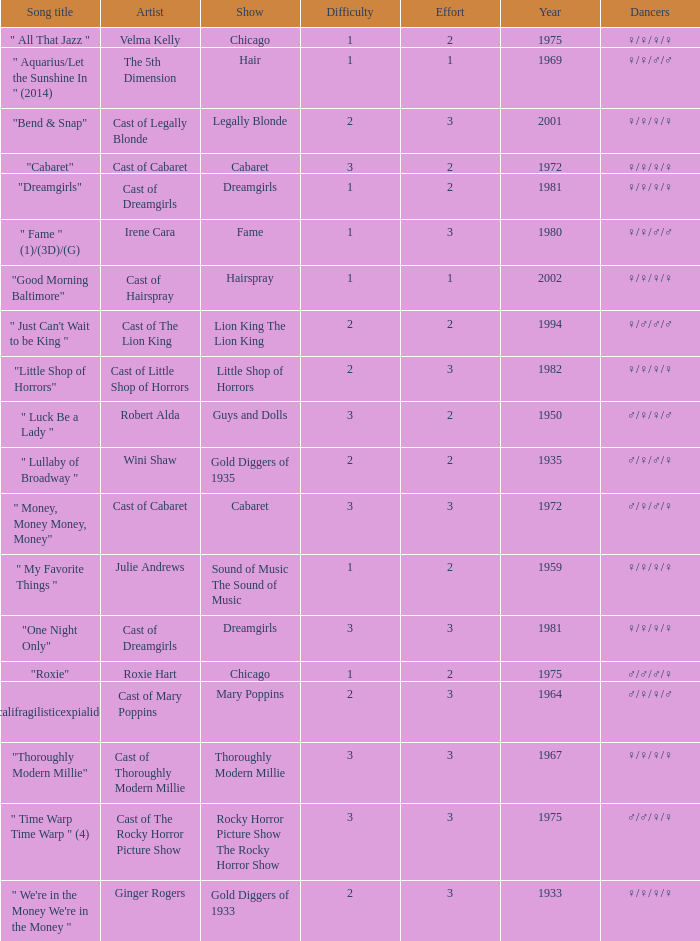What show featured the song "little shop of horrors"? Little Shop of Horrors. 